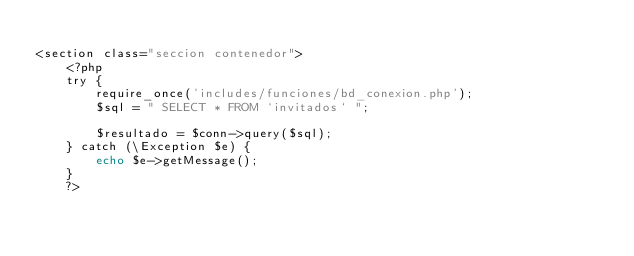Convert code to text. <code><loc_0><loc_0><loc_500><loc_500><_PHP_>
<section class="seccion contenedor">
    <?php
    try {
        require_once('includes/funciones/bd_conexion.php');
        $sql = " SELECT * FROM `invitados` ";

        $resultado = $conn->query($sql);
    } catch (\Exception $e) {
        echo $e->getMessage();
    }
    ?></code> 